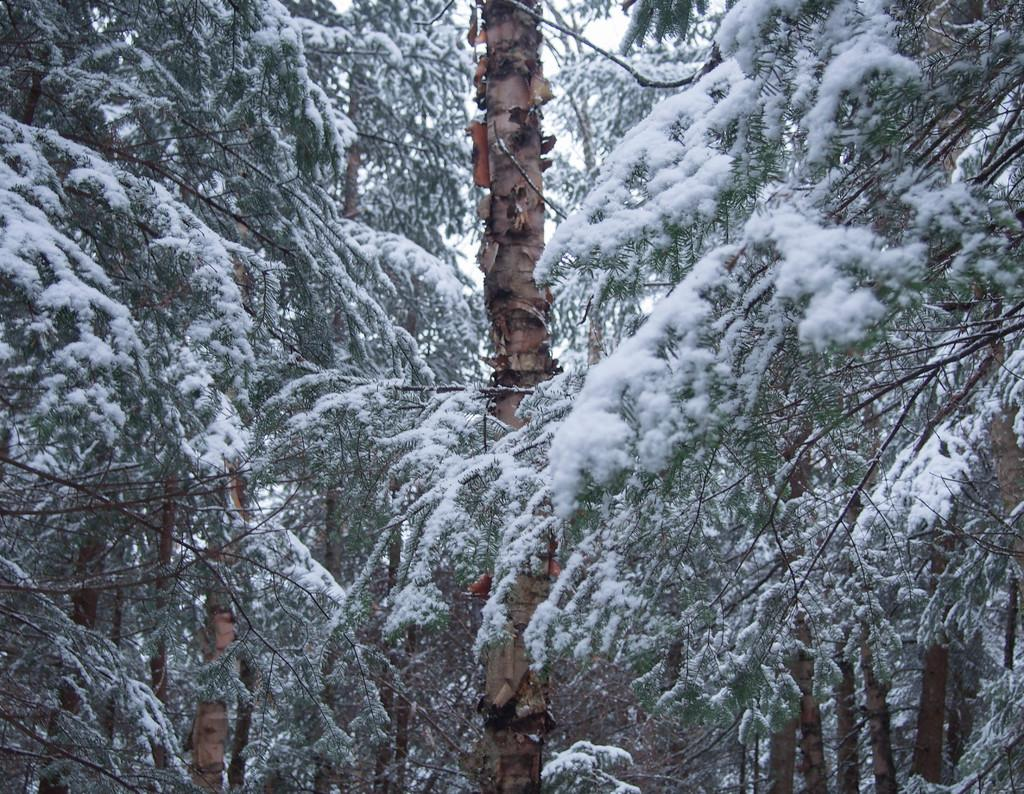What type of vegetation is present in the image? There are trees in the image. What is covering the trees in the image? The trees have snow on them. What type of nut can be seen growing on the trees in the image? There is no nut visible on the trees in the image, as they are covered in snow. 